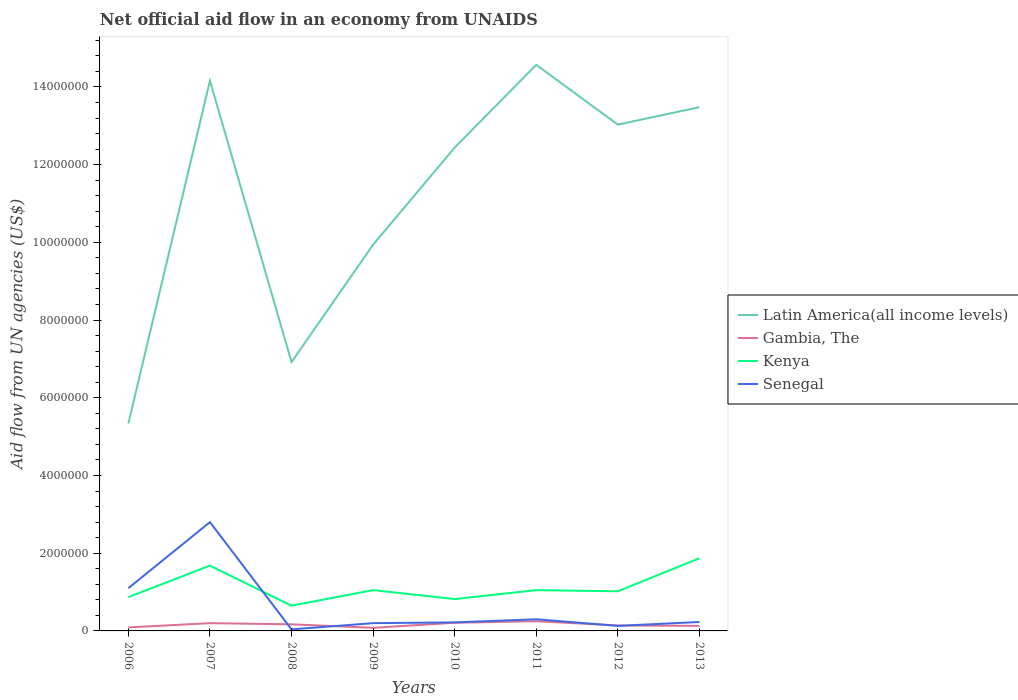Does the line corresponding to Gambia, The intersect with the line corresponding to Kenya?
Your answer should be very brief. No. Is the number of lines equal to the number of legend labels?
Make the answer very short. Yes. Across all years, what is the maximum net official aid flow in Latin America(all income levels)?
Give a very brief answer. 5.34e+06. In which year was the net official aid flow in Gambia, The maximum?
Ensure brevity in your answer.  2009. What is the total net official aid flow in Senegal in the graph?
Offer a terse response. -2.60e+05. What is the difference between the highest and the second highest net official aid flow in Kenya?
Give a very brief answer. 1.22e+06. What is the difference between the highest and the lowest net official aid flow in Kenya?
Provide a succinct answer. 2. Is the net official aid flow in Gambia, The strictly greater than the net official aid flow in Kenya over the years?
Offer a very short reply. Yes. How many lines are there?
Your answer should be compact. 4. What is the difference between two consecutive major ticks on the Y-axis?
Provide a short and direct response. 2.00e+06. How are the legend labels stacked?
Make the answer very short. Vertical. What is the title of the graph?
Provide a short and direct response. Net official aid flow in an economy from UNAIDS. Does "Djibouti" appear as one of the legend labels in the graph?
Offer a very short reply. No. What is the label or title of the Y-axis?
Your answer should be very brief. Aid flow from UN agencies (US$). What is the Aid flow from UN agencies (US$) of Latin America(all income levels) in 2006?
Ensure brevity in your answer.  5.34e+06. What is the Aid flow from UN agencies (US$) in Kenya in 2006?
Offer a very short reply. 8.70e+05. What is the Aid flow from UN agencies (US$) of Senegal in 2006?
Your answer should be compact. 1.10e+06. What is the Aid flow from UN agencies (US$) of Latin America(all income levels) in 2007?
Your answer should be compact. 1.42e+07. What is the Aid flow from UN agencies (US$) of Gambia, The in 2007?
Provide a succinct answer. 2.00e+05. What is the Aid flow from UN agencies (US$) in Kenya in 2007?
Offer a very short reply. 1.68e+06. What is the Aid flow from UN agencies (US$) in Senegal in 2007?
Make the answer very short. 2.80e+06. What is the Aid flow from UN agencies (US$) of Latin America(all income levels) in 2008?
Your response must be concise. 6.92e+06. What is the Aid flow from UN agencies (US$) of Gambia, The in 2008?
Provide a succinct answer. 1.70e+05. What is the Aid flow from UN agencies (US$) in Kenya in 2008?
Keep it short and to the point. 6.50e+05. What is the Aid flow from UN agencies (US$) of Latin America(all income levels) in 2009?
Your answer should be very brief. 9.94e+06. What is the Aid flow from UN agencies (US$) of Gambia, The in 2009?
Give a very brief answer. 8.00e+04. What is the Aid flow from UN agencies (US$) of Kenya in 2009?
Give a very brief answer. 1.05e+06. What is the Aid flow from UN agencies (US$) in Senegal in 2009?
Provide a short and direct response. 2.00e+05. What is the Aid flow from UN agencies (US$) of Latin America(all income levels) in 2010?
Ensure brevity in your answer.  1.24e+07. What is the Aid flow from UN agencies (US$) in Kenya in 2010?
Make the answer very short. 8.20e+05. What is the Aid flow from UN agencies (US$) of Senegal in 2010?
Your answer should be very brief. 2.20e+05. What is the Aid flow from UN agencies (US$) of Latin America(all income levels) in 2011?
Your answer should be compact. 1.46e+07. What is the Aid flow from UN agencies (US$) of Gambia, The in 2011?
Provide a short and direct response. 2.50e+05. What is the Aid flow from UN agencies (US$) in Kenya in 2011?
Your response must be concise. 1.05e+06. What is the Aid flow from UN agencies (US$) in Senegal in 2011?
Give a very brief answer. 3.00e+05. What is the Aid flow from UN agencies (US$) of Latin America(all income levels) in 2012?
Your response must be concise. 1.30e+07. What is the Aid flow from UN agencies (US$) of Kenya in 2012?
Provide a short and direct response. 1.02e+06. What is the Aid flow from UN agencies (US$) in Senegal in 2012?
Provide a short and direct response. 1.30e+05. What is the Aid flow from UN agencies (US$) of Latin America(all income levels) in 2013?
Your response must be concise. 1.35e+07. What is the Aid flow from UN agencies (US$) in Kenya in 2013?
Keep it short and to the point. 1.87e+06. Across all years, what is the maximum Aid flow from UN agencies (US$) of Latin America(all income levels)?
Make the answer very short. 1.46e+07. Across all years, what is the maximum Aid flow from UN agencies (US$) in Kenya?
Provide a succinct answer. 1.87e+06. Across all years, what is the maximum Aid flow from UN agencies (US$) in Senegal?
Keep it short and to the point. 2.80e+06. Across all years, what is the minimum Aid flow from UN agencies (US$) in Latin America(all income levels)?
Your response must be concise. 5.34e+06. Across all years, what is the minimum Aid flow from UN agencies (US$) in Gambia, The?
Offer a terse response. 8.00e+04. Across all years, what is the minimum Aid flow from UN agencies (US$) in Kenya?
Keep it short and to the point. 6.50e+05. What is the total Aid flow from UN agencies (US$) of Latin America(all income levels) in the graph?
Provide a succinct answer. 8.99e+07. What is the total Aid flow from UN agencies (US$) of Gambia, The in the graph?
Ensure brevity in your answer.  1.27e+06. What is the total Aid flow from UN agencies (US$) of Kenya in the graph?
Provide a succinct answer. 9.01e+06. What is the total Aid flow from UN agencies (US$) of Senegal in the graph?
Give a very brief answer. 5.02e+06. What is the difference between the Aid flow from UN agencies (US$) in Latin America(all income levels) in 2006 and that in 2007?
Offer a terse response. -8.82e+06. What is the difference between the Aid flow from UN agencies (US$) in Gambia, The in 2006 and that in 2007?
Offer a very short reply. -1.10e+05. What is the difference between the Aid flow from UN agencies (US$) of Kenya in 2006 and that in 2007?
Give a very brief answer. -8.10e+05. What is the difference between the Aid flow from UN agencies (US$) in Senegal in 2006 and that in 2007?
Provide a short and direct response. -1.70e+06. What is the difference between the Aid flow from UN agencies (US$) in Latin America(all income levels) in 2006 and that in 2008?
Your answer should be compact. -1.58e+06. What is the difference between the Aid flow from UN agencies (US$) of Gambia, The in 2006 and that in 2008?
Keep it short and to the point. -8.00e+04. What is the difference between the Aid flow from UN agencies (US$) of Senegal in 2006 and that in 2008?
Offer a very short reply. 1.06e+06. What is the difference between the Aid flow from UN agencies (US$) in Latin America(all income levels) in 2006 and that in 2009?
Your answer should be compact. -4.60e+06. What is the difference between the Aid flow from UN agencies (US$) of Gambia, The in 2006 and that in 2009?
Provide a succinct answer. 10000. What is the difference between the Aid flow from UN agencies (US$) in Kenya in 2006 and that in 2009?
Your answer should be very brief. -1.80e+05. What is the difference between the Aid flow from UN agencies (US$) of Senegal in 2006 and that in 2009?
Your response must be concise. 9.00e+05. What is the difference between the Aid flow from UN agencies (US$) of Latin America(all income levels) in 2006 and that in 2010?
Offer a very short reply. -7.10e+06. What is the difference between the Aid flow from UN agencies (US$) of Senegal in 2006 and that in 2010?
Your response must be concise. 8.80e+05. What is the difference between the Aid flow from UN agencies (US$) of Latin America(all income levels) in 2006 and that in 2011?
Your answer should be compact. -9.23e+06. What is the difference between the Aid flow from UN agencies (US$) of Latin America(all income levels) in 2006 and that in 2012?
Provide a short and direct response. -7.69e+06. What is the difference between the Aid flow from UN agencies (US$) in Gambia, The in 2006 and that in 2012?
Offer a very short reply. -5.00e+04. What is the difference between the Aid flow from UN agencies (US$) of Kenya in 2006 and that in 2012?
Offer a very short reply. -1.50e+05. What is the difference between the Aid flow from UN agencies (US$) in Senegal in 2006 and that in 2012?
Offer a very short reply. 9.70e+05. What is the difference between the Aid flow from UN agencies (US$) in Latin America(all income levels) in 2006 and that in 2013?
Your response must be concise. -8.14e+06. What is the difference between the Aid flow from UN agencies (US$) of Gambia, The in 2006 and that in 2013?
Provide a succinct answer. -4.00e+04. What is the difference between the Aid flow from UN agencies (US$) of Senegal in 2006 and that in 2013?
Make the answer very short. 8.70e+05. What is the difference between the Aid flow from UN agencies (US$) in Latin America(all income levels) in 2007 and that in 2008?
Provide a succinct answer. 7.24e+06. What is the difference between the Aid flow from UN agencies (US$) of Gambia, The in 2007 and that in 2008?
Offer a terse response. 3.00e+04. What is the difference between the Aid flow from UN agencies (US$) in Kenya in 2007 and that in 2008?
Your answer should be compact. 1.03e+06. What is the difference between the Aid flow from UN agencies (US$) of Senegal in 2007 and that in 2008?
Provide a short and direct response. 2.76e+06. What is the difference between the Aid flow from UN agencies (US$) of Latin America(all income levels) in 2007 and that in 2009?
Give a very brief answer. 4.22e+06. What is the difference between the Aid flow from UN agencies (US$) in Gambia, The in 2007 and that in 2009?
Keep it short and to the point. 1.20e+05. What is the difference between the Aid flow from UN agencies (US$) of Kenya in 2007 and that in 2009?
Offer a terse response. 6.30e+05. What is the difference between the Aid flow from UN agencies (US$) in Senegal in 2007 and that in 2009?
Your response must be concise. 2.60e+06. What is the difference between the Aid flow from UN agencies (US$) of Latin America(all income levels) in 2007 and that in 2010?
Offer a terse response. 1.72e+06. What is the difference between the Aid flow from UN agencies (US$) of Gambia, The in 2007 and that in 2010?
Provide a short and direct response. -10000. What is the difference between the Aid flow from UN agencies (US$) of Kenya in 2007 and that in 2010?
Your answer should be compact. 8.60e+05. What is the difference between the Aid flow from UN agencies (US$) of Senegal in 2007 and that in 2010?
Offer a very short reply. 2.58e+06. What is the difference between the Aid flow from UN agencies (US$) in Latin America(all income levels) in 2007 and that in 2011?
Provide a short and direct response. -4.10e+05. What is the difference between the Aid flow from UN agencies (US$) in Kenya in 2007 and that in 2011?
Your answer should be very brief. 6.30e+05. What is the difference between the Aid flow from UN agencies (US$) in Senegal in 2007 and that in 2011?
Offer a terse response. 2.50e+06. What is the difference between the Aid flow from UN agencies (US$) in Latin America(all income levels) in 2007 and that in 2012?
Provide a short and direct response. 1.13e+06. What is the difference between the Aid flow from UN agencies (US$) in Senegal in 2007 and that in 2012?
Keep it short and to the point. 2.67e+06. What is the difference between the Aid flow from UN agencies (US$) in Latin America(all income levels) in 2007 and that in 2013?
Keep it short and to the point. 6.80e+05. What is the difference between the Aid flow from UN agencies (US$) in Gambia, The in 2007 and that in 2013?
Your answer should be very brief. 7.00e+04. What is the difference between the Aid flow from UN agencies (US$) in Senegal in 2007 and that in 2013?
Offer a very short reply. 2.57e+06. What is the difference between the Aid flow from UN agencies (US$) of Latin America(all income levels) in 2008 and that in 2009?
Your response must be concise. -3.02e+06. What is the difference between the Aid flow from UN agencies (US$) of Gambia, The in 2008 and that in 2009?
Keep it short and to the point. 9.00e+04. What is the difference between the Aid flow from UN agencies (US$) in Kenya in 2008 and that in 2009?
Your answer should be very brief. -4.00e+05. What is the difference between the Aid flow from UN agencies (US$) of Senegal in 2008 and that in 2009?
Give a very brief answer. -1.60e+05. What is the difference between the Aid flow from UN agencies (US$) of Latin America(all income levels) in 2008 and that in 2010?
Provide a short and direct response. -5.52e+06. What is the difference between the Aid flow from UN agencies (US$) of Senegal in 2008 and that in 2010?
Your answer should be very brief. -1.80e+05. What is the difference between the Aid flow from UN agencies (US$) of Latin America(all income levels) in 2008 and that in 2011?
Your answer should be very brief. -7.65e+06. What is the difference between the Aid flow from UN agencies (US$) in Kenya in 2008 and that in 2011?
Your answer should be very brief. -4.00e+05. What is the difference between the Aid flow from UN agencies (US$) in Latin America(all income levels) in 2008 and that in 2012?
Make the answer very short. -6.11e+06. What is the difference between the Aid flow from UN agencies (US$) in Kenya in 2008 and that in 2012?
Your answer should be very brief. -3.70e+05. What is the difference between the Aid flow from UN agencies (US$) in Senegal in 2008 and that in 2012?
Give a very brief answer. -9.00e+04. What is the difference between the Aid flow from UN agencies (US$) of Latin America(all income levels) in 2008 and that in 2013?
Your response must be concise. -6.56e+06. What is the difference between the Aid flow from UN agencies (US$) in Kenya in 2008 and that in 2013?
Make the answer very short. -1.22e+06. What is the difference between the Aid flow from UN agencies (US$) in Latin America(all income levels) in 2009 and that in 2010?
Make the answer very short. -2.50e+06. What is the difference between the Aid flow from UN agencies (US$) in Gambia, The in 2009 and that in 2010?
Provide a short and direct response. -1.30e+05. What is the difference between the Aid flow from UN agencies (US$) of Latin America(all income levels) in 2009 and that in 2011?
Offer a very short reply. -4.63e+06. What is the difference between the Aid flow from UN agencies (US$) in Kenya in 2009 and that in 2011?
Your answer should be compact. 0. What is the difference between the Aid flow from UN agencies (US$) of Latin America(all income levels) in 2009 and that in 2012?
Make the answer very short. -3.09e+06. What is the difference between the Aid flow from UN agencies (US$) of Senegal in 2009 and that in 2012?
Offer a terse response. 7.00e+04. What is the difference between the Aid flow from UN agencies (US$) in Latin America(all income levels) in 2009 and that in 2013?
Make the answer very short. -3.54e+06. What is the difference between the Aid flow from UN agencies (US$) of Kenya in 2009 and that in 2013?
Your answer should be compact. -8.20e+05. What is the difference between the Aid flow from UN agencies (US$) of Senegal in 2009 and that in 2013?
Provide a succinct answer. -3.00e+04. What is the difference between the Aid flow from UN agencies (US$) in Latin America(all income levels) in 2010 and that in 2011?
Your answer should be compact. -2.13e+06. What is the difference between the Aid flow from UN agencies (US$) of Gambia, The in 2010 and that in 2011?
Offer a very short reply. -4.00e+04. What is the difference between the Aid flow from UN agencies (US$) of Kenya in 2010 and that in 2011?
Your answer should be very brief. -2.30e+05. What is the difference between the Aid flow from UN agencies (US$) in Senegal in 2010 and that in 2011?
Provide a short and direct response. -8.00e+04. What is the difference between the Aid flow from UN agencies (US$) of Latin America(all income levels) in 2010 and that in 2012?
Ensure brevity in your answer.  -5.90e+05. What is the difference between the Aid flow from UN agencies (US$) of Gambia, The in 2010 and that in 2012?
Ensure brevity in your answer.  7.00e+04. What is the difference between the Aid flow from UN agencies (US$) in Senegal in 2010 and that in 2012?
Give a very brief answer. 9.00e+04. What is the difference between the Aid flow from UN agencies (US$) in Latin America(all income levels) in 2010 and that in 2013?
Make the answer very short. -1.04e+06. What is the difference between the Aid flow from UN agencies (US$) of Gambia, The in 2010 and that in 2013?
Provide a short and direct response. 8.00e+04. What is the difference between the Aid flow from UN agencies (US$) of Kenya in 2010 and that in 2013?
Keep it short and to the point. -1.05e+06. What is the difference between the Aid flow from UN agencies (US$) of Latin America(all income levels) in 2011 and that in 2012?
Give a very brief answer. 1.54e+06. What is the difference between the Aid flow from UN agencies (US$) of Gambia, The in 2011 and that in 2012?
Give a very brief answer. 1.10e+05. What is the difference between the Aid flow from UN agencies (US$) in Kenya in 2011 and that in 2012?
Make the answer very short. 3.00e+04. What is the difference between the Aid flow from UN agencies (US$) of Latin America(all income levels) in 2011 and that in 2013?
Keep it short and to the point. 1.09e+06. What is the difference between the Aid flow from UN agencies (US$) of Kenya in 2011 and that in 2013?
Give a very brief answer. -8.20e+05. What is the difference between the Aid flow from UN agencies (US$) in Senegal in 2011 and that in 2013?
Give a very brief answer. 7.00e+04. What is the difference between the Aid flow from UN agencies (US$) of Latin America(all income levels) in 2012 and that in 2013?
Ensure brevity in your answer.  -4.50e+05. What is the difference between the Aid flow from UN agencies (US$) in Kenya in 2012 and that in 2013?
Your response must be concise. -8.50e+05. What is the difference between the Aid flow from UN agencies (US$) of Latin America(all income levels) in 2006 and the Aid flow from UN agencies (US$) of Gambia, The in 2007?
Your response must be concise. 5.14e+06. What is the difference between the Aid flow from UN agencies (US$) in Latin America(all income levels) in 2006 and the Aid flow from UN agencies (US$) in Kenya in 2007?
Your answer should be compact. 3.66e+06. What is the difference between the Aid flow from UN agencies (US$) of Latin America(all income levels) in 2006 and the Aid flow from UN agencies (US$) of Senegal in 2007?
Provide a short and direct response. 2.54e+06. What is the difference between the Aid flow from UN agencies (US$) of Gambia, The in 2006 and the Aid flow from UN agencies (US$) of Kenya in 2007?
Offer a terse response. -1.59e+06. What is the difference between the Aid flow from UN agencies (US$) of Gambia, The in 2006 and the Aid flow from UN agencies (US$) of Senegal in 2007?
Your answer should be compact. -2.71e+06. What is the difference between the Aid flow from UN agencies (US$) of Kenya in 2006 and the Aid flow from UN agencies (US$) of Senegal in 2007?
Offer a terse response. -1.93e+06. What is the difference between the Aid flow from UN agencies (US$) of Latin America(all income levels) in 2006 and the Aid flow from UN agencies (US$) of Gambia, The in 2008?
Your response must be concise. 5.17e+06. What is the difference between the Aid flow from UN agencies (US$) in Latin America(all income levels) in 2006 and the Aid flow from UN agencies (US$) in Kenya in 2008?
Make the answer very short. 4.69e+06. What is the difference between the Aid flow from UN agencies (US$) in Latin America(all income levels) in 2006 and the Aid flow from UN agencies (US$) in Senegal in 2008?
Give a very brief answer. 5.30e+06. What is the difference between the Aid flow from UN agencies (US$) in Gambia, The in 2006 and the Aid flow from UN agencies (US$) in Kenya in 2008?
Give a very brief answer. -5.60e+05. What is the difference between the Aid flow from UN agencies (US$) in Kenya in 2006 and the Aid flow from UN agencies (US$) in Senegal in 2008?
Make the answer very short. 8.30e+05. What is the difference between the Aid flow from UN agencies (US$) in Latin America(all income levels) in 2006 and the Aid flow from UN agencies (US$) in Gambia, The in 2009?
Give a very brief answer. 5.26e+06. What is the difference between the Aid flow from UN agencies (US$) of Latin America(all income levels) in 2006 and the Aid flow from UN agencies (US$) of Kenya in 2009?
Provide a short and direct response. 4.29e+06. What is the difference between the Aid flow from UN agencies (US$) in Latin America(all income levels) in 2006 and the Aid flow from UN agencies (US$) in Senegal in 2009?
Your answer should be very brief. 5.14e+06. What is the difference between the Aid flow from UN agencies (US$) in Gambia, The in 2006 and the Aid flow from UN agencies (US$) in Kenya in 2009?
Your answer should be compact. -9.60e+05. What is the difference between the Aid flow from UN agencies (US$) in Kenya in 2006 and the Aid flow from UN agencies (US$) in Senegal in 2009?
Offer a very short reply. 6.70e+05. What is the difference between the Aid flow from UN agencies (US$) of Latin America(all income levels) in 2006 and the Aid flow from UN agencies (US$) of Gambia, The in 2010?
Offer a very short reply. 5.13e+06. What is the difference between the Aid flow from UN agencies (US$) in Latin America(all income levels) in 2006 and the Aid flow from UN agencies (US$) in Kenya in 2010?
Offer a terse response. 4.52e+06. What is the difference between the Aid flow from UN agencies (US$) in Latin America(all income levels) in 2006 and the Aid flow from UN agencies (US$) in Senegal in 2010?
Ensure brevity in your answer.  5.12e+06. What is the difference between the Aid flow from UN agencies (US$) of Gambia, The in 2006 and the Aid flow from UN agencies (US$) of Kenya in 2010?
Ensure brevity in your answer.  -7.30e+05. What is the difference between the Aid flow from UN agencies (US$) in Gambia, The in 2006 and the Aid flow from UN agencies (US$) in Senegal in 2010?
Give a very brief answer. -1.30e+05. What is the difference between the Aid flow from UN agencies (US$) of Kenya in 2006 and the Aid flow from UN agencies (US$) of Senegal in 2010?
Your answer should be compact. 6.50e+05. What is the difference between the Aid flow from UN agencies (US$) of Latin America(all income levels) in 2006 and the Aid flow from UN agencies (US$) of Gambia, The in 2011?
Provide a succinct answer. 5.09e+06. What is the difference between the Aid flow from UN agencies (US$) in Latin America(all income levels) in 2006 and the Aid flow from UN agencies (US$) in Kenya in 2011?
Ensure brevity in your answer.  4.29e+06. What is the difference between the Aid flow from UN agencies (US$) of Latin America(all income levels) in 2006 and the Aid flow from UN agencies (US$) of Senegal in 2011?
Your response must be concise. 5.04e+06. What is the difference between the Aid flow from UN agencies (US$) in Gambia, The in 2006 and the Aid flow from UN agencies (US$) in Kenya in 2011?
Make the answer very short. -9.60e+05. What is the difference between the Aid flow from UN agencies (US$) in Gambia, The in 2006 and the Aid flow from UN agencies (US$) in Senegal in 2011?
Offer a terse response. -2.10e+05. What is the difference between the Aid flow from UN agencies (US$) in Kenya in 2006 and the Aid flow from UN agencies (US$) in Senegal in 2011?
Ensure brevity in your answer.  5.70e+05. What is the difference between the Aid flow from UN agencies (US$) of Latin America(all income levels) in 2006 and the Aid flow from UN agencies (US$) of Gambia, The in 2012?
Give a very brief answer. 5.20e+06. What is the difference between the Aid flow from UN agencies (US$) in Latin America(all income levels) in 2006 and the Aid flow from UN agencies (US$) in Kenya in 2012?
Your response must be concise. 4.32e+06. What is the difference between the Aid flow from UN agencies (US$) of Latin America(all income levels) in 2006 and the Aid flow from UN agencies (US$) of Senegal in 2012?
Provide a short and direct response. 5.21e+06. What is the difference between the Aid flow from UN agencies (US$) of Gambia, The in 2006 and the Aid flow from UN agencies (US$) of Kenya in 2012?
Offer a very short reply. -9.30e+05. What is the difference between the Aid flow from UN agencies (US$) of Kenya in 2006 and the Aid flow from UN agencies (US$) of Senegal in 2012?
Ensure brevity in your answer.  7.40e+05. What is the difference between the Aid flow from UN agencies (US$) in Latin America(all income levels) in 2006 and the Aid flow from UN agencies (US$) in Gambia, The in 2013?
Offer a terse response. 5.21e+06. What is the difference between the Aid flow from UN agencies (US$) in Latin America(all income levels) in 2006 and the Aid flow from UN agencies (US$) in Kenya in 2013?
Make the answer very short. 3.47e+06. What is the difference between the Aid flow from UN agencies (US$) of Latin America(all income levels) in 2006 and the Aid flow from UN agencies (US$) of Senegal in 2013?
Provide a succinct answer. 5.11e+06. What is the difference between the Aid flow from UN agencies (US$) in Gambia, The in 2006 and the Aid flow from UN agencies (US$) in Kenya in 2013?
Make the answer very short. -1.78e+06. What is the difference between the Aid flow from UN agencies (US$) of Gambia, The in 2006 and the Aid flow from UN agencies (US$) of Senegal in 2013?
Provide a succinct answer. -1.40e+05. What is the difference between the Aid flow from UN agencies (US$) of Kenya in 2006 and the Aid flow from UN agencies (US$) of Senegal in 2013?
Provide a succinct answer. 6.40e+05. What is the difference between the Aid flow from UN agencies (US$) of Latin America(all income levels) in 2007 and the Aid flow from UN agencies (US$) of Gambia, The in 2008?
Offer a terse response. 1.40e+07. What is the difference between the Aid flow from UN agencies (US$) in Latin America(all income levels) in 2007 and the Aid flow from UN agencies (US$) in Kenya in 2008?
Provide a short and direct response. 1.35e+07. What is the difference between the Aid flow from UN agencies (US$) of Latin America(all income levels) in 2007 and the Aid flow from UN agencies (US$) of Senegal in 2008?
Keep it short and to the point. 1.41e+07. What is the difference between the Aid flow from UN agencies (US$) of Gambia, The in 2007 and the Aid flow from UN agencies (US$) of Kenya in 2008?
Make the answer very short. -4.50e+05. What is the difference between the Aid flow from UN agencies (US$) in Gambia, The in 2007 and the Aid flow from UN agencies (US$) in Senegal in 2008?
Give a very brief answer. 1.60e+05. What is the difference between the Aid flow from UN agencies (US$) in Kenya in 2007 and the Aid flow from UN agencies (US$) in Senegal in 2008?
Keep it short and to the point. 1.64e+06. What is the difference between the Aid flow from UN agencies (US$) of Latin America(all income levels) in 2007 and the Aid flow from UN agencies (US$) of Gambia, The in 2009?
Provide a short and direct response. 1.41e+07. What is the difference between the Aid flow from UN agencies (US$) in Latin America(all income levels) in 2007 and the Aid flow from UN agencies (US$) in Kenya in 2009?
Offer a terse response. 1.31e+07. What is the difference between the Aid flow from UN agencies (US$) in Latin America(all income levels) in 2007 and the Aid flow from UN agencies (US$) in Senegal in 2009?
Your answer should be very brief. 1.40e+07. What is the difference between the Aid flow from UN agencies (US$) in Gambia, The in 2007 and the Aid flow from UN agencies (US$) in Kenya in 2009?
Provide a short and direct response. -8.50e+05. What is the difference between the Aid flow from UN agencies (US$) in Gambia, The in 2007 and the Aid flow from UN agencies (US$) in Senegal in 2009?
Provide a short and direct response. 0. What is the difference between the Aid flow from UN agencies (US$) of Kenya in 2007 and the Aid flow from UN agencies (US$) of Senegal in 2009?
Your answer should be compact. 1.48e+06. What is the difference between the Aid flow from UN agencies (US$) of Latin America(all income levels) in 2007 and the Aid flow from UN agencies (US$) of Gambia, The in 2010?
Offer a terse response. 1.40e+07. What is the difference between the Aid flow from UN agencies (US$) of Latin America(all income levels) in 2007 and the Aid flow from UN agencies (US$) of Kenya in 2010?
Ensure brevity in your answer.  1.33e+07. What is the difference between the Aid flow from UN agencies (US$) in Latin America(all income levels) in 2007 and the Aid flow from UN agencies (US$) in Senegal in 2010?
Make the answer very short. 1.39e+07. What is the difference between the Aid flow from UN agencies (US$) of Gambia, The in 2007 and the Aid flow from UN agencies (US$) of Kenya in 2010?
Offer a terse response. -6.20e+05. What is the difference between the Aid flow from UN agencies (US$) of Gambia, The in 2007 and the Aid flow from UN agencies (US$) of Senegal in 2010?
Offer a terse response. -2.00e+04. What is the difference between the Aid flow from UN agencies (US$) in Kenya in 2007 and the Aid flow from UN agencies (US$) in Senegal in 2010?
Make the answer very short. 1.46e+06. What is the difference between the Aid flow from UN agencies (US$) in Latin America(all income levels) in 2007 and the Aid flow from UN agencies (US$) in Gambia, The in 2011?
Provide a succinct answer. 1.39e+07. What is the difference between the Aid flow from UN agencies (US$) in Latin America(all income levels) in 2007 and the Aid flow from UN agencies (US$) in Kenya in 2011?
Make the answer very short. 1.31e+07. What is the difference between the Aid flow from UN agencies (US$) of Latin America(all income levels) in 2007 and the Aid flow from UN agencies (US$) of Senegal in 2011?
Offer a terse response. 1.39e+07. What is the difference between the Aid flow from UN agencies (US$) of Gambia, The in 2007 and the Aid flow from UN agencies (US$) of Kenya in 2011?
Provide a succinct answer. -8.50e+05. What is the difference between the Aid flow from UN agencies (US$) of Kenya in 2007 and the Aid flow from UN agencies (US$) of Senegal in 2011?
Make the answer very short. 1.38e+06. What is the difference between the Aid flow from UN agencies (US$) in Latin America(all income levels) in 2007 and the Aid flow from UN agencies (US$) in Gambia, The in 2012?
Ensure brevity in your answer.  1.40e+07. What is the difference between the Aid flow from UN agencies (US$) of Latin America(all income levels) in 2007 and the Aid flow from UN agencies (US$) of Kenya in 2012?
Your answer should be compact. 1.31e+07. What is the difference between the Aid flow from UN agencies (US$) of Latin America(all income levels) in 2007 and the Aid flow from UN agencies (US$) of Senegal in 2012?
Offer a terse response. 1.40e+07. What is the difference between the Aid flow from UN agencies (US$) in Gambia, The in 2007 and the Aid flow from UN agencies (US$) in Kenya in 2012?
Offer a terse response. -8.20e+05. What is the difference between the Aid flow from UN agencies (US$) in Kenya in 2007 and the Aid flow from UN agencies (US$) in Senegal in 2012?
Make the answer very short. 1.55e+06. What is the difference between the Aid flow from UN agencies (US$) in Latin America(all income levels) in 2007 and the Aid flow from UN agencies (US$) in Gambia, The in 2013?
Provide a succinct answer. 1.40e+07. What is the difference between the Aid flow from UN agencies (US$) of Latin America(all income levels) in 2007 and the Aid flow from UN agencies (US$) of Kenya in 2013?
Your response must be concise. 1.23e+07. What is the difference between the Aid flow from UN agencies (US$) in Latin America(all income levels) in 2007 and the Aid flow from UN agencies (US$) in Senegal in 2013?
Make the answer very short. 1.39e+07. What is the difference between the Aid flow from UN agencies (US$) of Gambia, The in 2007 and the Aid flow from UN agencies (US$) of Kenya in 2013?
Offer a very short reply. -1.67e+06. What is the difference between the Aid flow from UN agencies (US$) in Gambia, The in 2007 and the Aid flow from UN agencies (US$) in Senegal in 2013?
Your response must be concise. -3.00e+04. What is the difference between the Aid flow from UN agencies (US$) in Kenya in 2007 and the Aid flow from UN agencies (US$) in Senegal in 2013?
Make the answer very short. 1.45e+06. What is the difference between the Aid flow from UN agencies (US$) of Latin America(all income levels) in 2008 and the Aid flow from UN agencies (US$) of Gambia, The in 2009?
Offer a terse response. 6.84e+06. What is the difference between the Aid flow from UN agencies (US$) in Latin America(all income levels) in 2008 and the Aid flow from UN agencies (US$) in Kenya in 2009?
Make the answer very short. 5.87e+06. What is the difference between the Aid flow from UN agencies (US$) of Latin America(all income levels) in 2008 and the Aid flow from UN agencies (US$) of Senegal in 2009?
Offer a terse response. 6.72e+06. What is the difference between the Aid flow from UN agencies (US$) of Gambia, The in 2008 and the Aid flow from UN agencies (US$) of Kenya in 2009?
Your answer should be very brief. -8.80e+05. What is the difference between the Aid flow from UN agencies (US$) of Gambia, The in 2008 and the Aid flow from UN agencies (US$) of Senegal in 2009?
Make the answer very short. -3.00e+04. What is the difference between the Aid flow from UN agencies (US$) of Latin America(all income levels) in 2008 and the Aid flow from UN agencies (US$) of Gambia, The in 2010?
Offer a very short reply. 6.71e+06. What is the difference between the Aid flow from UN agencies (US$) of Latin America(all income levels) in 2008 and the Aid flow from UN agencies (US$) of Kenya in 2010?
Offer a terse response. 6.10e+06. What is the difference between the Aid flow from UN agencies (US$) of Latin America(all income levels) in 2008 and the Aid flow from UN agencies (US$) of Senegal in 2010?
Provide a short and direct response. 6.70e+06. What is the difference between the Aid flow from UN agencies (US$) in Gambia, The in 2008 and the Aid flow from UN agencies (US$) in Kenya in 2010?
Your answer should be compact. -6.50e+05. What is the difference between the Aid flow from UN agencies (US$) of Gambia, The in 2008 and the Aid flow from UN agencies (US$) of Senegal in 2010?
Give a very brief answer. -5.00e+04. What is the difference between the Aid flow from UN agencies (US$) in Latin America(all income levels) in 2008 and the Aid flow from UN agencies (US$) in Gambia, The in 2011?
Your response must be concise. 6.67e+06. What is the difference between the Aid flow from UN agencies (US$) in Latin America(all income levels) in 2008 and the Aid flow from UN agencies (US$) in Kenya in 2011?
Offer a very short reply. 5.87e+06. What is the difference between the Aid flow from UN agencies (US$) of Latin America(all income levels) in 2008 and the Aid flow from UN agencies (US$) of Senegal in 2011?
Keep it short and to the point. 6.62e+06. What is the difference between the Aid flow from UN agencies (US$) of Gambia, The in 2008 and the Aid flow from UN agencies (US$) of Kenya in 2011?
Provide a succinct answer. -8.80e+05. What is the difference between the Aid flow from UN agencies (US$) of Gambia, The in 2008 and the Aid flow from UN agencies (US$) of Senegal in 2011?
Provide a succinct answer. -1.30e+05. What is the difference between the Aid flow from UN agencies (US$) of Kenya in 2008 and the Aid flow from UN agencies (US$) of Senegal in 2011?
Your answer should be very brief. 3.50e+05. What is the difference between the Aid flow from UN agencies (US$) in Latin America(all income levels) in 2008 and the Aid flow from UN agencies (US$) in Gambia, The in 2012?
Offer a terse response. 6.78e+06. What is the difference between the Aid flow from UN agencies (US$) of Latin America(all income levels) in 2008 and the Aid flow from UN agencies (US$) of Kenya in 2012?
Offer a very short reply. 5.90e+06. What is the difference between the Aid flow from UN agencies (US$) in Latin America(all income levels) in 2008 and the Aid flow from UN agencies (US$) in Senegal in 2012?
Offer a very short reply. 6.79e+06. What is the difference between the Aid flow from UN agencies (US$) of Gambia, The in 2008 and the Aid flow from UN agencies (US$) of Kenya in 2012?
Provide a succinct answer. -8.50e+05. What is the difference between the Aid flow from UN agencies (US$) in Gambia, The in 2008 and the Aid flow from UN agencies (US$) in Senegal in 2012?
Give a very brief answer. 4.00e+04. What is the difference between the Aid flow from UN agencies (US$) of Kenya in 2008 and the Aid flow from UN agencies (US$) of Senegal in 2012?
Give a very brief answer. 5.20e+05. What is the difference between the Aid flow from UN agencies (US$) of Latin America(all income levels) in 2008 and the Aid flow from UN agencies (US$) of Gambia, The in 2013?
Make the answer very short. 6.79e+06. What is the difference between the Aid flow from UN agencies (US$) in Latin America(all income levels) in 2008 and the Aid flow from UN agencies (US$) in Kenya in 2013?
Keep it short and to the point. 5.05e+06. What is the difference between the Aid flow from UN agencies (US$) of Latin America(all income levels) in 2008 and the Aid flow from UN agencies (US$) of Senegal in 2013?
Your answer should be very brief. 6.69e+06. What is the difference between the Aid flow from UN agencies (US$) of Gambia, The in 2008 and the Aid flow from UN agencies (US$) of Kenya in 2013?
Your answer should be very brief. -1.70e+06. What is the difference between the Aid flow from UN agencies (US$) of Kenya in 2008 and the Aid flow from UN agencies (US$) of Senegal in 2013?
Keep it short and to the point. 4.20e+05. What is the difference between the Aid flow from UN agencies (US$) of Latin America(all income levels) in 2009 and the Aid flow from UN agencies (US$) of Gambia, The in 2010?
Make the answer very short. 9.73e+06. What is the difference between the Aid flow from UN agencies (US$) in Latin America(all income levels) in 2009 and the Aid flow from UN agencies (US$) in Kenya in 2010?
Make the answer very short. 9.12e+06. What is the difference between the Aid flow from UN agencies (US$) of Latin America(all income levels) in 2009 and the Aid flow from UN agencies (US$) of Senegal in 2010?
Offer a very short reply. 9.72e+06. What is the difference between the Aid flow from UN agencies (US$) in Gambia, The in 2009 and the Aid flow from UN agencies (US$) in Kenya in 2010?
Give a very brief answer. -7.40e+05. What is the difference between the Aid flow from UN agencies (US$) in Gambia, The in 2009 and the Aid flow from UN agencies (US$) in Senegal in 2010?
Offer a terse response. -1.40e+05. What is the difference between the Aid flow from UN agencies (US$) in Kenya in 2009 and the Aid flow from UN agencies (US$) in Senegal in 2010?
Keep it short and to the point. 8.30e+05. What is the difference between the Aid flow from UN agencies (US$) in Latin America(all income levels) in 2009 and the Aid flow from UN agencies (US$) in Gambia, The in 2011?
Offer a very short reply. 9.69e+06. What is the difference between the Aid flow from UN agencies (US$) of Latin America(all income levels) in 2009 and the Aid flow from UN agencies (US$) of Kenya in 2011?
Give a very brief answer. 8.89e+06. What is the difference between the Aid flow from UN agencies (US$) in Latin America(all income levels) in 2009 and the Aid flow from UN agencies (US$) in Senegal in 2011?
Ensure brevity in your answer.  9.64e+06. What is the difference between the Aid flow from UN agencies (US$) of Gambia, The in 2009 and the Aid flow from UN agencies (US$) of Kenya in 2011?
Make the answer very short. -9.70e+05. What is the difference between the Aid flow from UN agencies (US$) in Kenya in 2009 and the Aid flow from UN agencies (US$) in Senegal in 2011?
Your response must be concise. 7.50e+05. What is the difference between the Aid flow from UN agencies (US$) of Latin America(all income levels) in 2009 and the Aid flow from UN agencies (US$) of Gambia, The in 2012?
Ensure brevity in your answer.  9.80e+06. What is the difference between the Aid flow from UN agencies (US$) of Latin America(all income levels) in 2009 and the Aid flow from UN agencies (US$) of Kenya in 2012?
Make the answer very short. 8.92e+06. What is the difference between the Aid flow from UN agencies (US$) of Latin America(all income levels) in 2009 and the Aid flow from UN agencies (US$) of Senegal in 2012?
Your answer should be compact. 9.81e+06. What is the difference between the Aid flow from UN agencies (US$) of Gambia, The in 2009 and the Aid flow from UN agencies (US$) of Kenya in 2012?
Provide a short and direct response. -9.40e+05. What is the difference between the Aid flow from UN agencies (US$) of Kenya in 2009 and the Aid flow from UN agencies (US$) of Senegal in 2012?
Your answer should be compact. 9.20e+05. What is the difference between the Aid flow from UN agencies (US$) in Latin America(all income levels) in 2009 and the Aid flow from UN agencies (US$) in Gambia, The in 2013?
Offer a terse response. 9.81e+06. What is the difference between the Aid flow from UN agencies (US$) in Latin America(all income levels) in 2009 and the Aid flow from UN agencies (US$) in Kenya in 2013?
Give a very brief answer. 8.07e+06. What is the difference between the Aid flow from UN agencies (US$) in Latin America(all income levels) in 2009 and the Aid flow from UN agencies (US$) in Senegal in 2013?
Offer a terse response. 9.71e+06. What is the difference between the Aid flow from UN agencies (US$) of Gambia, The in 2009 and the Aid flow from UN agencies (US$) of Kenya in 2013?
Provide a short and direct response. -1.79e+06. What is the difference between the Aid flow from UN agencies (US$) of Gambia, The in 2009 and the Aid flow from UN agencies (US$) of Senegal in 2013?
Keep it short and to the point. -1.50e+05. What is the difference between the Aid flow from UN agencies (US$) of Kenya in 2009 and the Aid flow from UN agencies (US$) of Senegal in 2013?
Your response must be concise. 8.20e+05. What is the difference between the Aid flow from UN agencies (US$) of Latin America(all income levels) in 2010 and the Aid flow from UN agencies (US$) of Gambia, The in 2011?
Provide a succinct answer. 1.22e+07. What is the difference between the Aid flow from UN agencies (US$) in Latin America(all income levels) in 2010 and the Aid flow from UN agencies (US$) in Kenya in 2011?
Your answer should be compact. 1.14e+07. What is the difference between the Aid flow from UN agencies (US$) in Latin America(all income levels) in 2010 and the Aid flow from UN agencies (US$) in Senegal in 2011?
Your answer should be compact. 1.21e+07. What is the difference between the Aid flow from UN agencies (US$) in Gambia, The in 2010 and the Aid flow from UN agencies (US$) in Kenya in 2011?
Give a very brief answer. -8.40e+05. What is the difference between the Aid flow from UN agencies (US$) of Gambia, The in 2010 and the Aid flow from UN agencies (US$) of Senegal in 2011?
Your response must be concise. -9.00e+04. What is the difference between the Aid flow from UN agencies (US$) in Kenya in 2010 and the Aid flow from UN agencies (US$) in Senegal in 2011?
Provide a short and direct response. 5.20e+05. What is the difference between the Aid flow from UN agencies (US$) in Latin America(all income levels) in 2010 and the Aid flow from UN agencies (US$) in Gambia, The in 2012?
Offer a terse response. 1.23e+07. What is the difference between the Aid flow from UN agencies (US$) in Latin America(all income levels) in 2010 and the Aid flow from UN agencies (US$) in Kenya in 2012?
Give a very brief answer. 1.14e+07. What is the difference between the Aid flow from UN agencies (US$) in Latin America(all income levels) in 2010 and the Aid flow from UN agencies (US$) in Senegal in 2012?
Provide a succinct answer. 1.23e+07. What is the difference between the Aid flow from UN agencies (US$) of Gambia, The in 2010 and the Aid flow from UN agencies (US$) of Kenya in 2012?
Keep it short and to the point. -8.10e+05. What is the difference between the Aid flow from UN agencies (US$) of Gambia, The in 2010 and the Aid flow from UN agencies (US$) of Senegal in 2012?
Provide a succinct answer. 8.00e+04. What is the difference between the Aid flow from UN agencies (US$) of Kenya in 2010 and the Aid flow from UN agencies (US$) of Senegal in 2012?
Keep it short and to the point. 6.90e+05. What is the difference between the Aid flow from UN agencies (US$) of Latin America(all income levels) in 2010 and the Aid flow from UN agencies (US$) of Gambia, The in 2013?
Keep it short and to the point. 1.23e+07. What is the difference between the Aid flow from UN agencies (US$) in Latin America(all income levels) in 2010 and the Aid flow from UN agencies (US$) in Kenya in 2013?
Give a very brief answer. 1.06e+07. What is the difference between the Aid flow from UN agencies (US$) in Latin America(all income levels) in 2010 and the Aid flow from UN agencies (US$) in Senegal in 2013?
Your answer should be compact. 1.22e+07. What is the difference between the Aid flow from UN agencies (US$) in Gambia, The in 2010 and the Aid flow from UN agencies (US$) in Kenya in 2013?
Your answer should be compact. -1.66e+06. What is the difference between the Aid flow from UN agencies (US$) of Gambia, The in 2010 and the Aid flow from UN agencies (US$) of Senegal in 2013?
Your answer should be very brief. -2.00e+04. What is the difference between the Aid flow from UN agencies (US$) in Kenya in 2010 and the Aid flow from UN agencies (US$) in Senegal in 2013?
Keep it short and to the point. 5.90e+05. What is the difference between the Aid flow from UN agencies (US$) in Latin America(all income levels) in 2011 and the Aid flow from UN agencies (US$) in Gambia, The in 2012?
Offer a very short reply. 1.44e+07. What is the difference between the Aid flow from UN agencies (US$) in Latin America(all income levels) in 2011 and the Aid flow from UN agencies (US$) in Kenya in 2012?
Ensure brevity in your answer.  1.36e+07. What is the difference between the Aid flow from UN agencies (US$) of Latin America(all income levels) in 2011 and the Aid flow from UN agencies (US$) of Senegal in 2012?
Keep it short and to the point. 1.44e+07. What is the difference between the Aid flow from UN agencies (US$) in Gambia, The in 2011 and the Aid flow from UN agencies (US$) in Kenya in 2012?
Your response must be concise. -7.70e+05. What is the difference between the Aid flow from UN agencies (US$) in Kenya in 2011 and the Aid flow from UN agencies (US$) in Senegal in 2012?
Offer a very short reply. 9.20e+05. What is the difference between the Aid flow from UN agencies (US$) of Latin America(all income levels) in 2011 and the Aid flow from UN agencies (US$) of Gambia, The in 2013?
Your response must be concise. 1.44e+07. What is the difference between the Aid flow from UN agencies (US$) in Latin America(all income levels) in 2011 and the Aid flow from UN agencies (US$) in Kenya in 2013?
Give a very brief answer. 1.27e+07. What is the difference between the Aid flow from UN agencies (US$) of Latin America(all income levels) in 2011 and the Aid flow from UN agencies (US$) of Senegal in 2013?
Offer a very short reply. 1.43e+07. What is the difference between the Aid flow from UN agencies (US$) in Gambia, The in 2011 and the Aid flow from UN agencies (US$) in Kenya in 2013?
Your response must be concise. -1.62e+06. What is the difference between the Aid flow from UN agencies (US$) of Gambia, The in 2011 and the Aid flow from UN agencies (US$) of Senegal in 2013?
Provide a short and direct response. 2.00e+04. What is the difference between the Aid flow from UN agencies (US$) of Kenya in 2011 and the Aid flow from UN agencies (US$) of Senegal in 2013?
Offer a very short reply. 8.20e+05. What is the difference between the Aid flow from UN agencies (US$) in Latin America(all income levels) in 2012 and the Aid flow from UN agencies (US$) in Gambia, The in 2013?
Make the answer very short. 1.29e+07. What is the difference between the Aid flow from UN agencies (US$) in Latin America(all income levels) in 2012 and the Aid flow from UN agencies (US$) in Kenya in 2013?
Your answer should be very brief. 1.12e+07. What is the difference between the Aid flow from UN agencies (US$) in Latin America(all income levels) in 2012 and the Aid flow from UN agencies (US$) in Senegal in 2013?
Give a very brief answer. 1.28e+07. What is the difference between the Aid flow from UN agencies (US$) in Gambia, The in 2012 and the Aid flow from UN agencies (US$) in Kenya in 2013?
Offer a very short reply. -1.73e+06. What is the difference between the Aid flow from UN agencies (US$) of Kenya in 2012 and the Aid flow from UN agencies (US$) of Senegal in 2013?
Offer a very short reply. 7.90e+05. What is the average Aid flow from UN agencies (US$) in Latin America(all income levels) per year?
Provide a short and direct response. 1.12e+07. What is the average Aid flow from UN agencies (US$) of Gambia, The per year?
Keep it short and to the point. 1.59e+05. What is the average Aid flow from UN agencies (US$) in Kenya per year?
Your answer should be very brief. 1.13e+06. What is the average Aid flow from UN agencies (US$) in Senegal per year?
Provide a succinct answer. 6.28e+05. In the year 2006, what is the difference between the Aid flow from UN agencies (US$) in Latin America(all income levels) and Aid flow from UN agencies (US$) in Gambia, The?
Ensure brevity in your answer.  5.25e+06. In the year 2006, what is the difference between the Aid flow from UN agencies (US$) in Latin America(all income levels) and Aid flow from UN agencies (US$) in Kenya?
Keep it short and to the point. 4.47e+06. In the year 2006, what is the difference between the Aid flow from UN agencies (US$) of Latin America(all income levels) and Aid flow from UN agencies (US$) of Senegal?
Offer a very short reply. 4.24e+06. In the year 2006, what is the difference between the Aid flow from UN agencies (US$) of Gambia, The and Aid flow from UN agencies (US$) of Kenya?
Give a very brief answer. -7.80e+05. In the year 2006, what is the difference between the Aid flow from UN agencies (US$) in Gambia, The and Aid flow from UN agencies (US$) in Senegal?
Give a very brief answer. -1.01e+06. In the year 2007, what is the difference between the Aid flow from UN agencies (US$) of Latin America(all income levels) and Aid flow from UN agencies (US$) of Gambia, The?
Your answer should be compact. 1.40e+07. In the year 2007, what is the difference between the Aid flow from UN agencies (US$) of Latin America(all income levels) and Aid flow from UN agencies (US$) of Kenya?
Make the answer very short. 1.25e+07. In the year 2007, what is the difference between the Aid flow from UN agencies (US$) of Latin America(all income levels) and Aid flow from UN agencies (US$) of Senegal?
Your answer should be very brief. 1.14e+07. In the year 2007, what is the difference between the Aid flow from UN agencies (US$) in Gambia, The and Aid flow from UN agencies (US$) in Kenya?
Offer a very short reply. -1.48e+06. In the year 2007, what is the difference between the Aid flow from UN agencies (US$) in Gambia, The and Aid flow from UN agencies (US$) in Senegal?
Your answer should be compact. -2.60e+06. In the year 2007, what is the difference between the Aid flow from UN agencies (US$) of Kenya and Aid flow from UN agencies (US$) of Senegal?
Offer a very short reply. -1.12e+06. In the year 2008, what is the difference between the Aid flow from UN agencies (US$) of Latin America(all income levels) and Aid flow from UN agencies (US$) of Gambia, The?
Keep it short and to the point. 6.75e+06. In the year 2008, what is the difference between the Aid flow from UN agencies (US$) in Latin America(all income levels) and Aid flow from UN agencies (US$) in Kenya?
Give a very brief answer. 6.27e+06. In the year 2008, what is the difference between the Aid flow from UN agencies (US$) in Latin America(all income levels) and Aid flow from UN agencies (US$) in Senegal?
Ensure brevity in your answer.  6.88e+06. In the year 2008, what is the difference between the Aid flow from UN agencies (US$) in Gambia, The and Aid flow from UN agencies (US$) in Kenya?
Provide a short and direct response. -4.80e+05. In the year 2008, what is the difference between the Aid flow from UN agencies (US$) of Gambia, The and Aid flow from UN agencies (US$) of Senegal?
Provide a short and direct response. 1.30e+05. In the year 2008, what is the difference between the Aid flow from UN agencies (US$) of Kenya and Aid flow from UN agencies (US$) of Senegal?
Offer a terse response. 6.10e+05. In the year 2009, what is the difference between the Aid flow from UN agencies (US$) of Latin America(all income levels) and Aid flow from UN agencies (US$) of Gambia, The?
Offer a very short reply. 9.86e+06. In the year 2009, what is the difference between the Aid flow from UN agencies (US$) of Latin America(all income levels) and Aid flow from UN agencies (US$) of Kenya?
Offer a terse response. 8.89e+06. In the year 2009, what is the difference between the Aid flow from UN agencies (US$) of Latin America(all income levels) and Aid flow from UN agencies (US$) of Senegal?
Give a very brief answer. 9.74e+06. In the year 2009, what is the difference between the Aid flow from UN agencies (US$) in Gambia, The and Aid flow from UN agencies (US$) in Kenya?
Keep it short and to the point. -9.70e+05. In the year 2009, what is the difference between the Aid flow from UN agencies (US$) in Gambia, The and Aid flow from UN agencies (US$) in Senegal?
Your response must be concise. -1.20e+05. In the year 2009, what is the difference between the Aid flow from UN agencies (US$) of Kenya and Aid flow from UN agencies (US$) of Senegal?
Offer a terse response. 8.50e+05. In the year 2010, what is the difference between the Aid flow from UN agencies (US$) of Latin America(all income levels) and Aid flow from UN agencies (US$) of Gambia, The?
Keep it short and to the point. 1.22e+07. In the year 2010, what is the difference between the Aid flow from UN agencies (US$) of Latin America(all income levels) and Aid flow from UN agencies (US$) of Kenya?
Give a very brief answer. 1.16e+07. In the year 2010, what is the difference between the Aid flow from UN agencies (US$) in Latin America(all income levels) and Aid flow from UN agencies (US$) in Senegal?
Your answer should be very brief. 1.22e+07. In the year 2010, what is the difference between the Aid flow from UN agencies (US$) in Gambia, The and Aid flow from UN agencies (US$) in Kenya?
Your answer should be very brief. -6.10e+05. In the year 2010, what is the difference between the Aid flow from UN agencies (US$) in Kenya and Aid flow from UN agencies (US$) in Senegal?
Your response must be concise. 6.00e+05. In the year 2011, what is the difference between the Aid flow from UN agencies (US$) in Latin America(all income levels) and Aid flow from UN agencies (US$) in Gambia, The?
Give a very brief answer. 1.43e+07. In the year 2011, what is the difference between the Aid flow from UN agencies (US$) of Latin America(all income levels) and Aid flow from UN agencies (US$) of Kenya?
Provide a short and direct response. 1.35e+07. In the year 2011, what is the difference between the Aid flow from UN agencies (US$) of Latin America(all income levels) and Aid flow from UN agencies (US$) of Senegal?
Give a very brief answer. 1.43e+07. In the year 2011, what is the difference between the Aid flow from UN agencies (US$) in Gambia, The and Aid flow from UN agencies (US$) in Kenya?
Ensure brevity in your answer.  -8.00e+05. In the year 2011, what is the difference between the Aid flow from UN agencies (US$) of Gambia, The and Aid flow from UN agencies (US$) of Senegal?
Provide a succinct answer. -5.00e+04. In the year 2011, what is the difference between the Aid flow from UN agencies (US$) in Kenya and Aid flow from UN agencies (US$) in Senegal?
Your response must be concise. 7.50e+05. In the year 2012, what is the difference between the Aid flow from UN agencies (US$) of Latin America(all income levels) and Aid flow from UN agencies (US$) of Gambia, The?
Keep it short and to the point. 1.29e+07. In the year 2012, what is the difference between the Aid flow from UN agencies (US$) of Latin America(all income levels) and Aid flow from UN agencies (US$) of Kenya?
Your answer should be compact. 1.20e+07. In the year 2012, what is the difference between the Aid flow from UN agencies (US$) of Latin America(all income levels) and Aid flow from UN agencies (US$) of Senegal?
Offer a very short reply. 1.29e+07. In the year 2012, what is the difference between the Aid flow from UN agencies (US$) of Gambia, The and Aid flow from UN agencies (US$) of Kenya?
Keep it short and to the point. -8.80e+05. In the year 2012, what is the difference between the Aid flow from UN agencies (US$) of Kenya and Aid flow from UN agencies (US$) of Senegal?
Your answer should be very brief. 8.90e+05. In the year 2013, what is the difference between the Aid flow from UN agencies (US$) of Latin America(all income levels) and Aid flow from UN agencies (US$) of Gambia, The?
Ensure brevity in your answer.  1.34e+07. In the year 2013, what is the difference between the Aid flow from UN agencies (US$) in Latin America(all income levels) and Aid flow from UN agencies (US$) in Kenya?
Give a very brief answer. 1.16e+07. In the year 2013, what is the difference between the Aid flow from UN agencies (US$) of Latin America(all income levels) and Aid flow from UN agencies (US$) of Senegal?
Offer a very short reply. 1.32e+07. In the year 2013, what is the difference between the Aid flow from UN agencies (US$) in Gambia, The and Aid flow from UN agencies (US$) in Kenya?
Your response must be concise. -1.74e+06. In the year 2013, what is the difference between the Aid flow from UN agencies (US$) of Kenya and Aid flow from UN agencies (US$) of Senegal?
Your response must be concise. 1.64e+06. What is the ratio of the Aid flow from UN agencies (US$) in Latin America(all income levels) in 2006 to that in 2007?
Offer a terse response. 0.38. What is the ratio of the Aid flow from UN agencies (US$) in Gambia, The in 2006 to that in 2007?
Give a very brief answer. 0.45. What is the ratio of the Aid flow from UN agencies (US$) in Kenya in 2006 to that in 2007?
Offer a terse response. 0.52. What is the ratio of the Aid flow from UN agencies (US$) in Senegal in 2006 to that in 2007?
Give a very brief answer. 0.39. What is the ratio of the Aid flow from UN agencies (US$) in Latin America(all income levels) in 2006 to that in 2008?
Provide a short and direct response. 0.77. What is the ratio of the Aid flow from UN agencies (US$) of Gambia, The in 2006 to that in 2008?
Offer a terse response. 0.53. What is the ratio of the Aid flow from UN agencies (US$) in Kenya in 2006 to that in 2008?
Offer a very short reply. 1.34. What is the ratio of the Aid flow from UN agencies (US$) in Latin America(all income levels) in 2006 to that in 2009?
Your answer should be compact. 0.54. What is the ratio of the Aid flow from UN agencies (US$) of Kenya in 2006 to that in 2009?
Ensure brevity in your answer.  0.83. What is the ratio of the Aid flow from UN agencies (US$) in Senegal in 2006 to that in 2009?
Provide a short and direct response. 5.5. What is the ratio of the Aid flow from UN agencies (US$) of Latin America(all income levels) in 2006 to that in 2010?
Ensure brevity in your answer.  0.43. What is the ratio of the Aid flow from UN agencies (US$) of Gambia, The in 2006 to that in 2010?
Offer a very short reply. 0.43. What is the ratio of the Aid flow from UN agencies (US$) of Kenya in 2006 to that in 2010?
Ensure brevity in your answer.  1.06. What is the ratio of the Aid flow from UN agencies (US$) in Latin America(all income levels) in 2006 to that in 2011?
Your answer should be very brief. 0.37. What is the ratio of the Aid flow from UN agencies (US$) of Gambia, The in 2006 to that in 2011?
Your answer should be compact. 0.36. What is the ratio of the Aid flow from UN agencies (US$) of Kenya in 2006 to that in 2011?
Keep it short and to the point. 0.83. What is the ratio of the Aid flow from UN agencies (US$) of Senegal in 2006 to that in 2011?
Your answer should be compact. 3.67. What is the ratio of the Aid flow from UN agencies (US$) in Latin America(all income levels) in 2006 to that in 2012?
Give a very brief answer. 0.41. What is the ratio of the Aid flow from UN agencies (US$) in Gambia, The in 2006 to that in 2012?
Your answer should be compact. 0.64. What is the ratio of the Aid flow from UN agencies (US$) in Kenya in 2006 to that in 2012?
Offer a very short reply. 0.85. What is the ratio of the Aid flow from UN agencies (US$) in Senegal in 2006 to that in 2012?
Give a very brief answer. 8.46. What is the ratio of the Aid flow from UN agencies (US$) of Latin America(all income levels) in 2006 to that in 2013?
Your answer should be compact. 0.4. What is the ratio of the Aid flow from UN agencies (US$) of Gambia, The in 2006 to that in 2013?
Keep it short and to the point. 0.69. What is the ratio of the Aid flow from UN agencies (US$) in Kenya in 2006 to that in 2013?
Keep it short and to the point. 0.47. What is the ratio of the Aid flow from UN agencies (US$) of Senegal in 2006 to that in 2013?
Offer a very short reply. 4.78. What is the ratio of the Aid flow from UN agencies (US$) in Latin America(all income levels) in 2007 to that in 2008?
Keep it short and to the point. 2.05. What is the ratio of the Aid flow from UN agencies (US$) of Gambia, The in 2007 to that in 2008?
Offer a very short reply. 1.18. What is the ratio of the Aid flow from UN agencies (US$) of Kenya in 2007 to that in 2008?
Make the answer very short. 2.58. What is the ratio of the Aid flow from UN agencies (US$) of Senegal in 2007 to that in 2008?
Keep it short and to the point. 70. What is the ratio of the Aid flow from UN agencies (US$) of Latin America(all income levels) in 2007 to that in 2009?
Your response must be concise. 1.42. What is the ratio of the Aid flow from UN agencies (US$) in Gambia, The in 2007 to that in 2009?
Your answer should be very brief. 2.5. What is the ratio of the Aid flow from UN agencies (US$) in Latin America(all income levels) in 2007 to that in 2010?
Make the answer very short. 1.14. What is the ratio of the Aid flow from UN agencies (US$) in Gambia, The in 2007 to that in 2010?
Your answer should be very brief. 0.95. What is the ratio of the Aid flow from UN agencies (US$) in Kenya in 2007 to that in 2010?
Provide a succinct answer. 2.05. What is the ratio of the Aid flow from UN agencies (US$) of Senegal in 2007 to that in 2010?
Make the answer very short. 12.73. What is the ratio of the Aid flow from UN agencies (US$) in Latin America(all income levels) in 2007 to that in 2011?
Provide a succinct answer. 0.97. What is the ratio of the Aid flow from UN agencies (US$) in Gambia, The in 2007 to that in 2011?
Give a very brief answer. 0.8. What is the ratio of the Aid flow from UN agencies (US$) in Kenya in 2007 to that in 2011?
Offer a terse response. 1.6. What is the ratio of the Aid flow from UN agencies (US$) of Senegal in 2007 to that in 2011?
Offer a very short reply. 9.33. What is the ratio of the Aid flow from UN agencies (US$) of Latin America(all income levels) in 2007 to that in 2012?
Give a very brief answer. 1.09. What is the ratio of the Aid flow from UN agencies (US$) in Gambia, The in 2007 to that in 2012?
Your answer should be compact. 1.43. What is the ratio of the Aid flow from UN agencies (US$) in Kenya in 2007 to that in 2012?
Provide a succinct answer. 1.65. What is the ratio of the Aid flow from UN agencies (US$) in Senegal in 2007 to that in 2012?
Make the answer very short. 21.54. What is the ratio of the Aid flow from UN agencies (US$) in Latin America(all income levels) in 2007 to that in 2013?
Provide a succinct answer. 1.05. What is the ratio of the Aid flow from UN agencies (US$) in Gambia, The in 2007 to that in 2013?
Offer a terse response. 1.54. What is the ratio of the Aid flow from UN agencies (US$) in Kenya in 2007 to that in 2013?
Keep it short and to the point. 0.9. What is the ratio of the Aid flow from UN agencies (US$) of Senegal in 2007 to that in 2013?
Offer a very short reply. 12.17. What is the ratio of the Aid flow from UN agencies (US$) in Latin America(all income levels) in 2008 to that in 2009?
Your answer should be very brief. 0.7. What is the ratio of the Aid flow from UN agencies (US$) in Gambia, The in 2008 to that in 2009?
Offer a very short reply. 2.12. What is the ratio of the Aid flow from UN agencies (US$) of Kenya in 2008 to that in 2009?
Keep it short and to the point. 0.62. What is the ratio of the Aid flow from UN agencies (US$) of Latin America(all income levels) in 2008 to that in 2010?
Give a very brief answer. 0.56. What is the ratio of the Aid flow from UN agencies (US$) of Gambia, The in 2008 to that in 2010?
Make the answer very short. 0.81. What is the ratio of the Aid flow from UN agencies (US$) in Kenya in 2008 to that in 2010?
Give a very brief answer. 0.79. What is the ratio of the Aid flow from UN agencies (US$) of Senegal in 2008 to that in 2010?
Offer a very short reply. 0.18. What is the ratio of the Aid flow from UN agencies (US$) in Latin America(all income levels) in 2008 to that in 2011?
Make the answer very short. 0.47. What is the ratio of the Aid flow from UN agencies (US$) in Gambia, The in 2008 to that in 2011?
Make the answer very short. 0.68. What is the ratio of the Aid flow from UN agencies (US$) in Kenya in 2008 to that in 2011?
Give a very brief answer. 0.62. What is the ratio of the Aid flow from UN agencies (US$) of Senegal in 2008 to that in 2011?
Provide a short and direct response. 0.13. What is the ratio of the Aid flow from UN agencies (US$) in Latin America(all income levels) in 2008 to that in 2012?
Give a very brief answer. 0.53. What is the ratio of the Aid flow from UN agencies (US$) of Gambia, The in 2008 to that in 2012?
Give a very brief answer. 1.21. What is the ratio of the Aid flow from UN agencies (US$) of Kenya in 2008 to that in 2012?
Offer a very short reply. 0.64. What is the ratio of the Aid flow from UN agencies (US$) in Senegal in 2008 to that in 2012?
Keep it short and to the point. 0.31. What is the ratio of the Aid flow from UN agencies (US$) of Latin America(all income levels) in 2008 to that in 2013?
Your answer should be very brief. 0.51. What is the ratio of the Aid flow from UN agencies (US$) of Gambia, The in 2008 to that in 2013?
Your answer should be compact. 1.31. What is the ratio of the Aid flow from UN agencies (US$) of Kenya in 2008 to that in 2013?
Offer a very short reply. 0.35. What is the ratio of the Aid flow from UN agencies (US$) in Senegal in 2008 to that in 2013?
Your answer should be very brief. 0.17. What is the ratio of the Aid flow from UN agencies (US$) of Latin America(all income levels) in 2009 to that in 2010?
Give a very brief answer. 0.8. What is the ratio of the Aid flow from UN agencies (US$) of Gambia, The in 2009 to that in 2010?
Provide a short and direct response. 0.38. What is the ratio of the Aid flow from UN agencies (US$) of Kenya in 2009 to that in 2010?
Provide a short and direct response. 1.28. What is the ratio of the Aid flow from UN agencies (US$) of Latin America(all income levels) in 2009 to that in 2011?
Offer a very short reply. 0.68. What is the ratio of the Aid flow from UN agencies (US$) in Gambia, The in 2009 to that in 2011?
Ensure brevity in your answer.  0.32. What is the ratio of the Aid flow from UN agencies (US$) of Senegal in 2009 to that in 2011?
Offer a terse response. 0.67. What is the ratio of the Aid flow from UN agencies (US$) of Latin America(all income levels) in 2009 to that in 2012?
Your answer should be compact. 0.76. What is the ratio of the Aid flow from UN agencies (US$) of Kenya in 2009 to that in 2012?
Your response must be concise. 1.03. What is the ratio of the Aid flow from UN agencies (US$) of Senegal in 2009 to that in 2012?
Your response must be concise. 1.54. What is the ratio of the Aid flow from UN agencies (US$) in Latin America(all income levels) in 2009 to that in 2013?
Offer a very short reply. 0.74. What is the ratio of the Aid flow from UN agencies (US$) in Gambia, The in 2009 to that in 2013?
Give a very brief answer. 0.62. What is the ratio of the Aid flow from UN agencies (US$) of Kenya in 2009 to that in 2013?
Offer a very short reply. 0.56. What is the ratio of the Aid flow from UN agencies (US$) in Senegal in 2009 to that in 2013?
Offer a terse response. 0.87. What is the ratio of the Aid flow from UN agencies (US$) in Latin America(all income levels) in 2010 to that in 2011?
Make the answer very short. 0.85. What is the ratio of the Aid flow from UN agencies (US$) of Gambia, The in 2010 to that in 2011?
Offer a very short reply. 0.84. What is the ratio of the Aid flow from UN agencies (US$) in Kenya in 2010 to that in 2011?
Provide a succinct answer. 0.78. What is the ratio of the Aid flow from UN agencies (US$) of Senegal in 2010 to that in 2011?
Make the answer very short. 0.73. What is the ratio of the Aid flow from UN agencies (US$) in Latin America(all income levels) in 2010 to that in 2012?
Keep it short and to the point. 0.95. What is the ratio of the Aid flow from UN agencies (US$) in Kenya in 2010 to that in 2012?
Provide a succinct answer. 0.8. What is the ratio of the Aid flow from UN agencies (US$) in Senegal in 2010 to that in 2012?
Provide a short and direct response. 1.69. What is the ratio of the Aid flow from UN agencies (US$) in Latin America(all income levels) in 2010 to that in 2013?
Provide a short and direct response. 0.92. What is the ratio of the Aid flow from UN agencies (US$) of Gambia, The in 2010 to that in 2013?
Your answer should be very brief. 1.62. What is the ratio of the Aid flow from UN agencies (US$) of Kenya in 2010 to that in 2013?
Offer a very short reply. 0.44. What is the ratio of the Aid flow from UN agencies (US$) of Senegal in 2010 to that in 2013?
Offer a terse response. 0.96. What is the ratio of the Aid flow from UN agencies (US$) of Latin America(all income levels) in 2011 to that in 2012?
Your response must be concise. 1.12. What is the ratio of the Aid flow from UN agencies (US$) of Gambia, The in 2011 to that in 2012?
Offer a terse response. 1.79. What is the ratio of the Aid flow from UN agencies (US$) in Kenya in 2011 to that in 2012?
Your answer should be very brief. 1.03. What is the ratio of the Aid flow from UN agencies (US$) of Senegal in 2011 to that in 2012?
Give a very brief answer. 2.31. What is the ratio of the Aid flow from UN agencies (US$) in Latin America(all income levels) in 2011 to that in 2013?
Provide a short and direct response. 1.08. What is the ratio of the Aid flow from UN agencies (US$) in Gambia, The in 2011 to that in 2013?
Offer a terse response. 1.92. What is the ratio of the Aid flow from UN agencies (US$) of Kenya in 2011 to that in 2013?
Provide a short and direct response. 0.56. What is the ratio of the Aid flow from UN agencies (US$) of Senegal in 2011 to that in 2013?
Give a very brief answer. 1.3. What is the ratio of the Aid flow from UN agencies (US$) of Latin America(all income levels) in 2012 to that in 2013?
Your response must be concise. 0.97. What is the ratio of the Aid flow from UN agencies (US$) in Kenya in 2012 to that in 2013?
Your response must be concise. 0.55. What is the ratio of the Aid flow from UN agencies (US$) of Senegal in 2012 to that in 2013?
Make the answer very short. 0.57. What is the difference between the highest and the second highest Aid flow from UN agencies (US$) of Latin America(all income levels)?
Your response must be concise. 4.10e+05. What is the difference between the highest and the second highest Aid flow from UN agencies (US$) in Gambia, The?
Keep it short and to the point. 4.00e+04. What is the difference between the highest and the second highest Aid flow from UN agencies (US$) in Kenya?
Keep it short and to the point. 1.90e+05. What is the difference between the highest and the second highest Aid flow from UN agencies (US$) of Senegal?
Offer a terse response. 1.70e+06. What is the difference between the highest and the lowest Aid flow from UN agencies (US$) in Latin America(all income levels)?
Your response must be concise. 9.23e+06. What is the difference between the highest and the lowest Aid flow from UN agencies (US$) of Kenya?
Your answer should be compact. 1.22e+06. What is the difference between the highest and the lowest Aid flow from UN agencies (US$) of Senegal?
Your answer should be compact. 2.76e+06. 